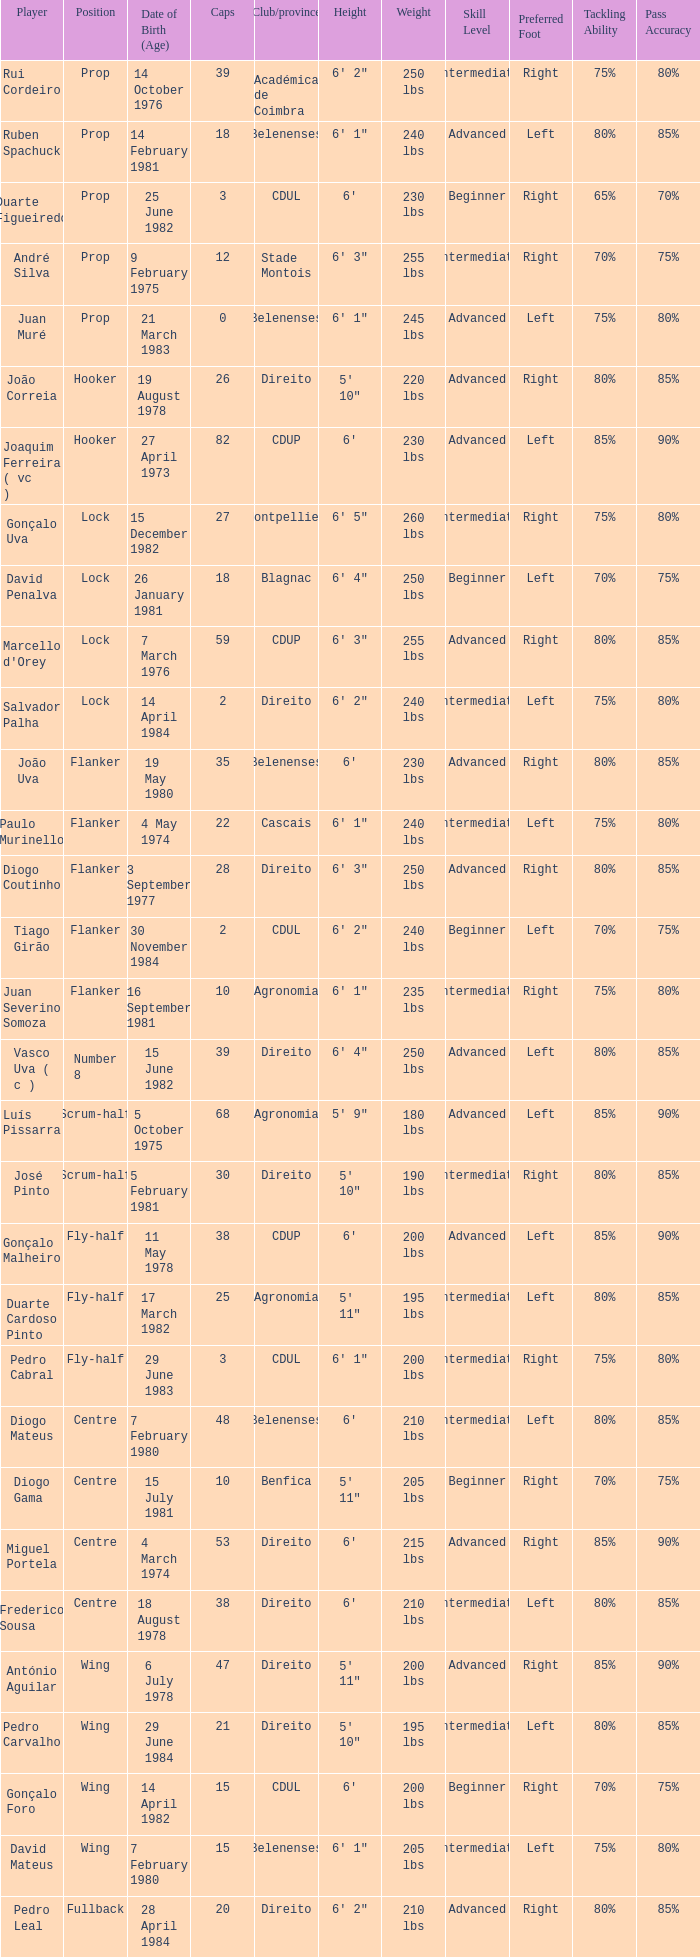How many caps have a Position of prop, and a Player of rui cordeiro? 1.0. 